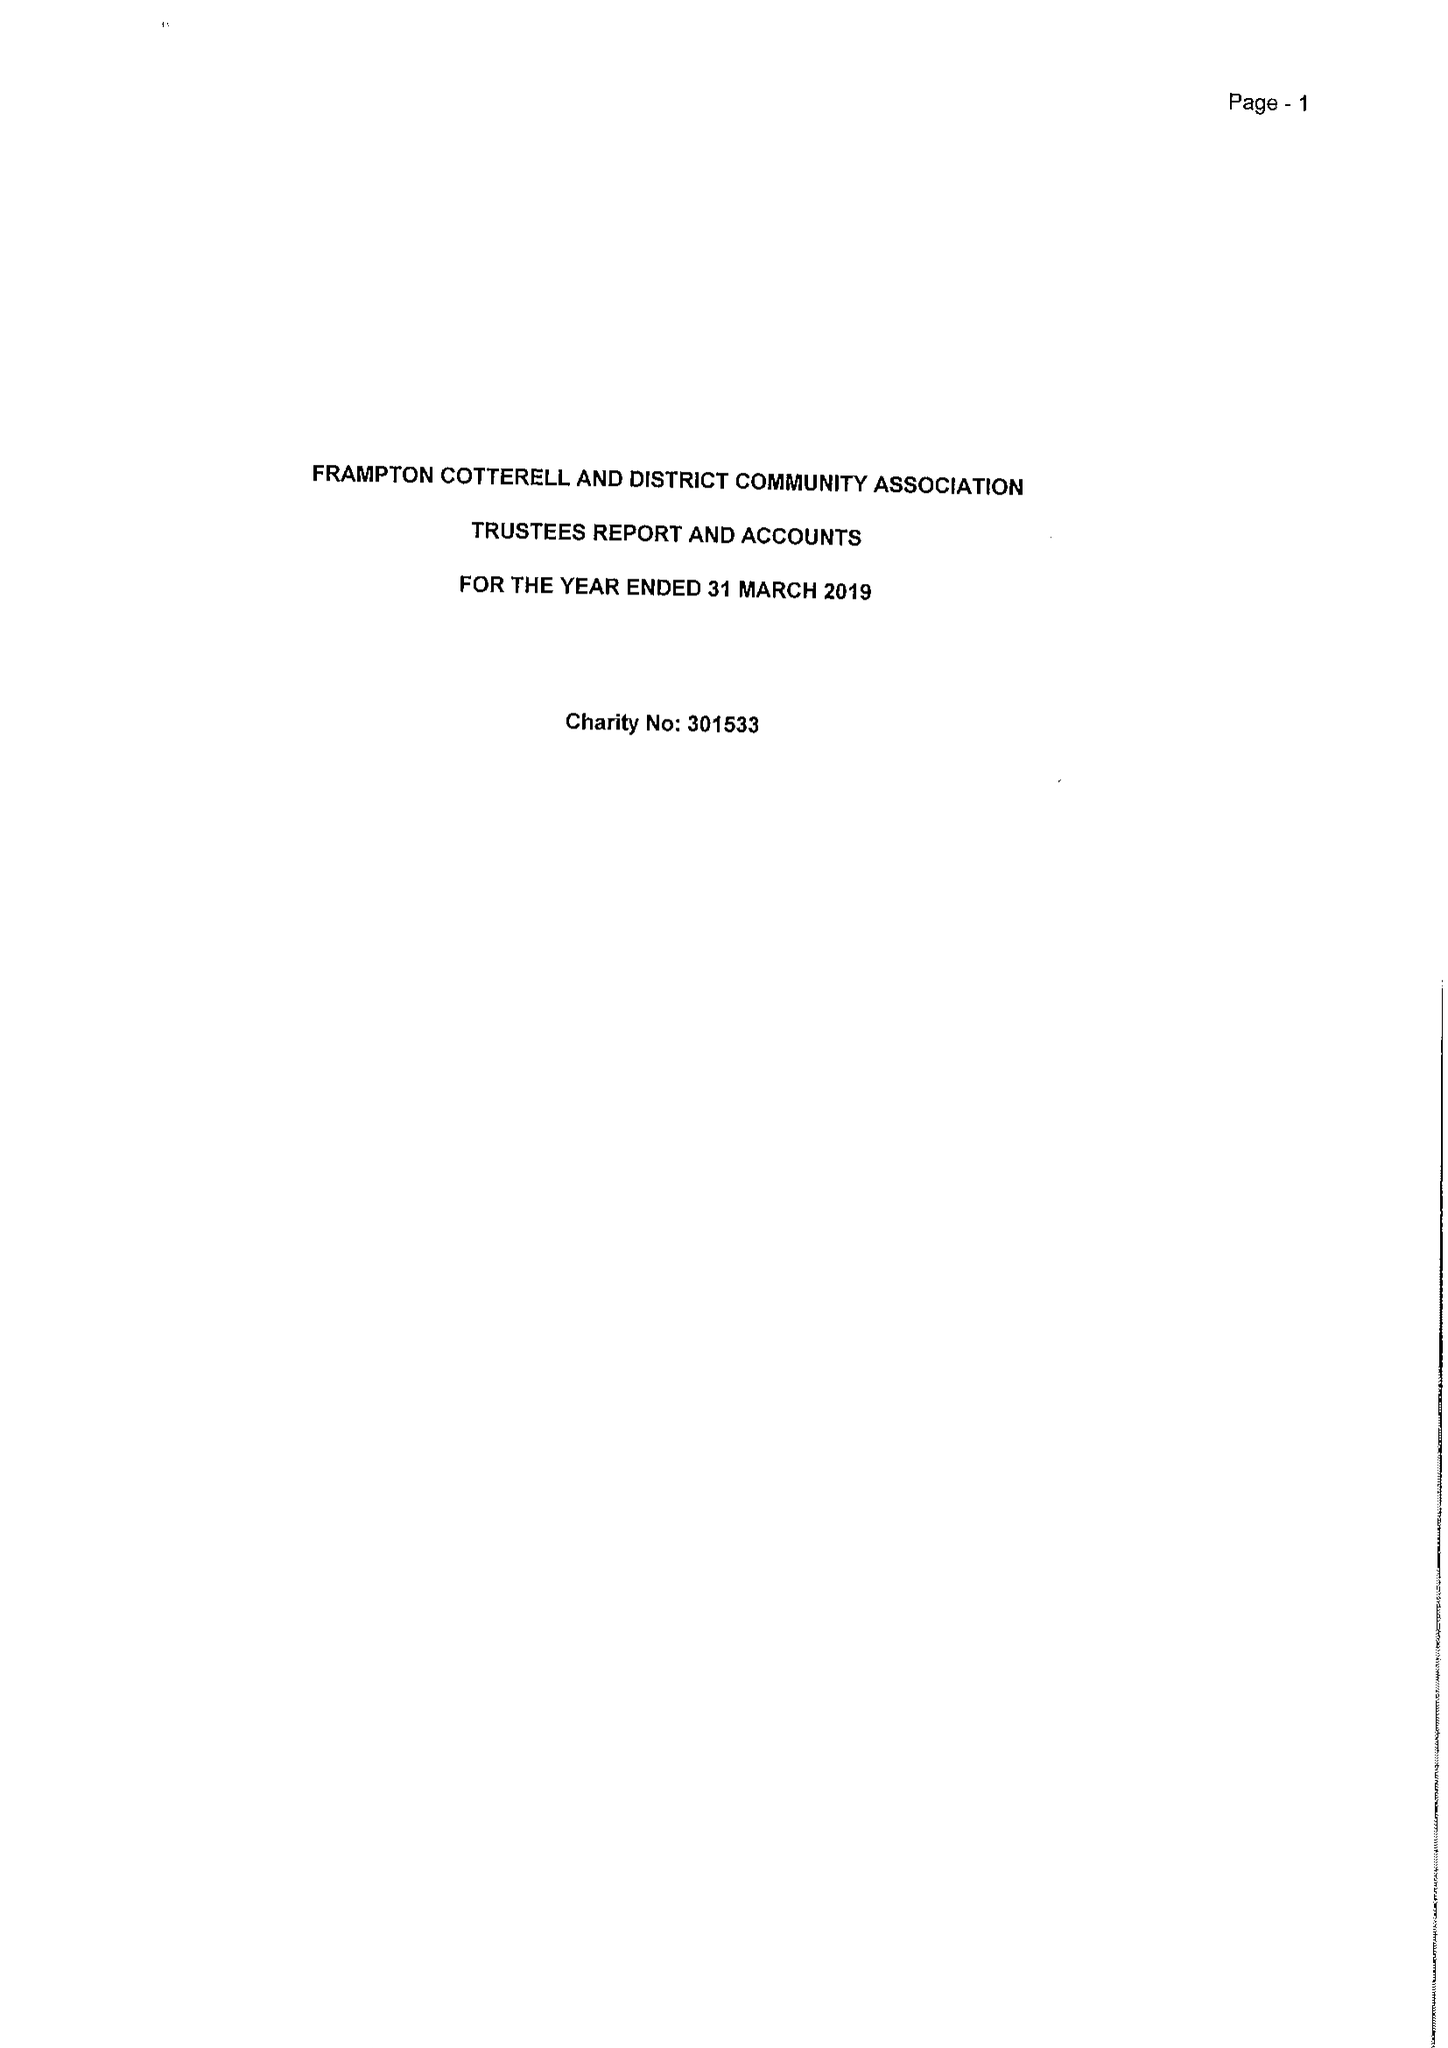What is the value for the spending_annually_in_british_pounds?
Answer the question using a single word or phrase. 37385.00 